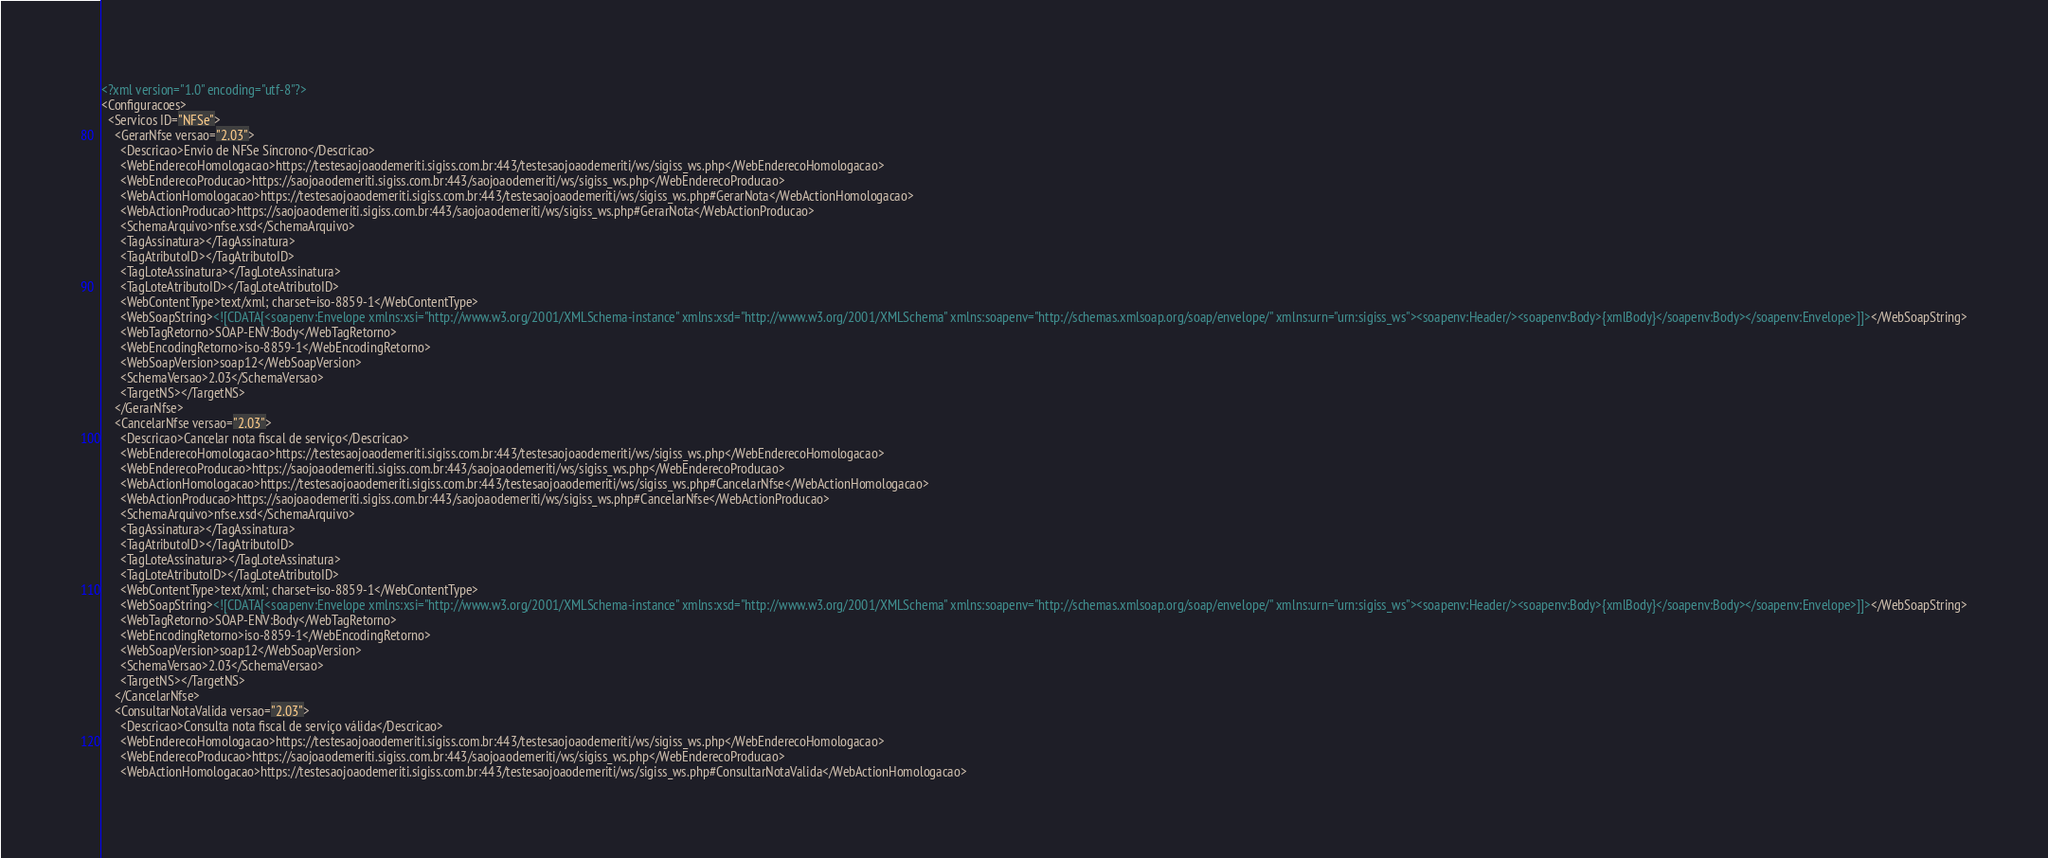<code> <loc_0><loc_0><loc_500><loc_500><_XML_><?xml version="1.0" encoding="utf-8"?>
<Configuracoes>
  <Servicos ID="NFSe">
    <GerarNfse versao="2.03">
      <Descricao>Envio de NFSe Síncrono</Descricao>
      <WebEnderecoHomologacao>https://testesaojoaodemeriti.sigiss.com.br:443/testesaojoaodemeriti/ws/sigiss_ws.php</WebEnderecoHomologacao>
      <WebEnderecoProducao>https://saojoaodemeriti.sigiss.com.br:443/saojoaodemeriti/ws/sigiss_ws.php</WebEnderecoProducao>
      <WebActionHomologacao>https://testesaojoaodemeriti.sigiss.com.br:443/testesaojoaodemeriti/ws/sigiss_ws.php#GerarNota</WebActionHomologacao>
      <WebActionProducao>https://saojoaodemeriti.sigiss.com.br:443/saojoaodemeriti/ws/sigiss_ws.php#GerarNota</WebActionProducao>
      <SchemaArquivo>nfse.xsd</SchemaArquivo>
      <TagAssinatura></TagAssinatura>
      <TagAtributoID></TagAtributoID>
      <TagLoteAssinatura></TagLoteAssinatura>
      <TagLoteAtributoID></TagLoteAtributoID>
      <WebContentType>text/xml; charset=iso-8859-1</WebContentType>
      <WebSoapString><![CDATA[<soapenv:Envelope xmlns:xsi="http://www.w3.org/2001/XMLSchema-instance" xmlns:xsd="http://www.w3.org/2001/XMLSchema" xmlns:soapenv="http://schemas.xmlsoap.org/soap/envelope/" xmlns:urn="urn:sigiss_ws"><soapenv:Header/><soapenv:Body>{xmlBody}</soapenv:Body></soapenv:Envelope>]]></WebSoapString>
      <WebTagRetorno>SOAP-ENV:Body</WebTagRetorno>
      <WebEncodingRetorno>iso-8859-1</WebEncodingRetorno>
      <WebSoapVersion>soap12</WebSoapVersion>
      <SchemaVersao>2.03</SchemaVersao>
      <TargetNS></TargetNS>
    </GerarNfse>
    <CancelarNfse versao="2.03">
      <Descricao>Cancelar nota fiscal de serviço</Descricao>
      <WebEnderecoHomologacao>https://testesaojoaodemeriti.sigiss.com.br:443/testesaojoaodemeriti/ws/sigiss_ws.php</WebEnderecoHomologacao>
      <WebEnderecoProducao>https://saojoaodemeriti.sigiss.com.br:443/saojoaodemeriti/ws/sigiss_ws.php</WebEnderecoProducao>
      <WebActionHomologacao>https://testesaojoaodemeriti.sigiss.com.br:443/testesaojoaodemeriti/ws/sigiss_ws.php#CancelarNfse</WebActionHomologacao>
      <WebActionProducao>https://saojoaodemeriti.sigiss.com.br:443/saojoaodemeriti/ws/sigiss_ws.php#CancelarNfse</WebActionProducao>
      <SchemaArquivo>nfse.xsd</SchemaArquivo>
      <TagAssinatura></TagAssinatura>
      <TagAtributoID></TagAtributoID>
      <TagLoteAssinatura></TagLoteAssinatura>
      <TagLoteAtributoID></TagLoteAtributoID>
      <WebContentType>text/xml; charset=iso-8859-1</WebContentType>
      <WebSoapString><![CDATA[<soapenv:Envelope xmlns:xsi="http://www.w3.org/2001/XMLSchema-instance" xmlns:xsd="http://www.w3.org/2001/XMLSchema" xmlns:soapenv="http://schemas.xmlsoap.org/soap/envelope/" xmlns:urn="urn:sigiss_ws"><soapenv:Header/><soapenv:Body>{xmlBody}</soapenv:Body></soapenv:Envelope>]]></WebSoapString>
      <WebTagRetorno>SOAP-ENV:Body</WebTagRetorno>
      <WebEncodingRetorno>iso-8859-1</WebEncodingRetorno>
      <WebSoapVersion>soap12</WebSoapVersion>
      <SchemaVersao>2.03</SchemaVersao>
      <TargetNS></TargetNS>
    </CancelarNfse>
    <ConsultarNotaValida versao="2.03">
      <Descricao>Consulta nota fiscal de serviço válida</Descricao>
      <WebEnderecoHomologacao>https://testesaojoaodemeriti.sigiss.com.br:443/testesaojoaodemeriti/ws/sigiss_ws.php</WebEnderecoHomologacao>
      <WebEnderecoProducao>https://saojoaodemeriti.sigiss.com.br:443/saojoaodemeriti/ws/sigiss_ws.php</WebEnderecoProducao>
      <WebActionHomologacao>https://testesaojoaodemeriti.sigiss.com.br:443/testesaojoaodemeriti/ws/sigiss_ws.php#ConsultarNotaValida</WebActionHomologacao></code> 